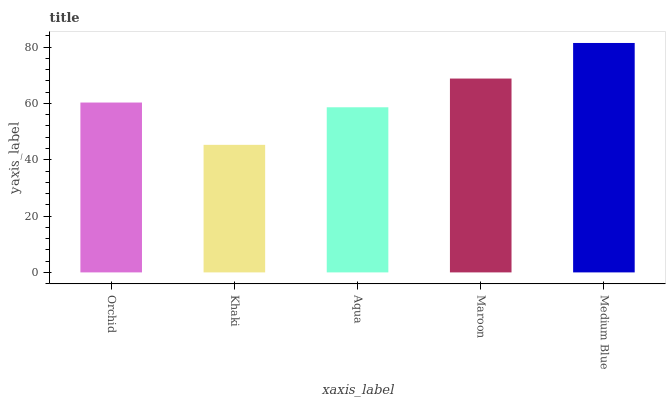Is Aqua the minimum?
Answer yes or no. No. Is Aqua the maximum?
Answer yes or no. No. Is Aqua greater than Khaki?
Answer yes or no. Yes. Is Khaki less than Aqua?
Answer yes or no. Yes. Is Khaki greater than Aqua?
Answer yes or no. No. Is Aqua less than Khaki?
Answer yes or no. No. Is Orchid the high median?
Answer yes or no. Yes. Is Orchid the low median?
Answer yes or no. Yes. Is Medium Blue the high median?
Answer yes or no. No. Is Khaki the low median?
Answer yes or no. No. 